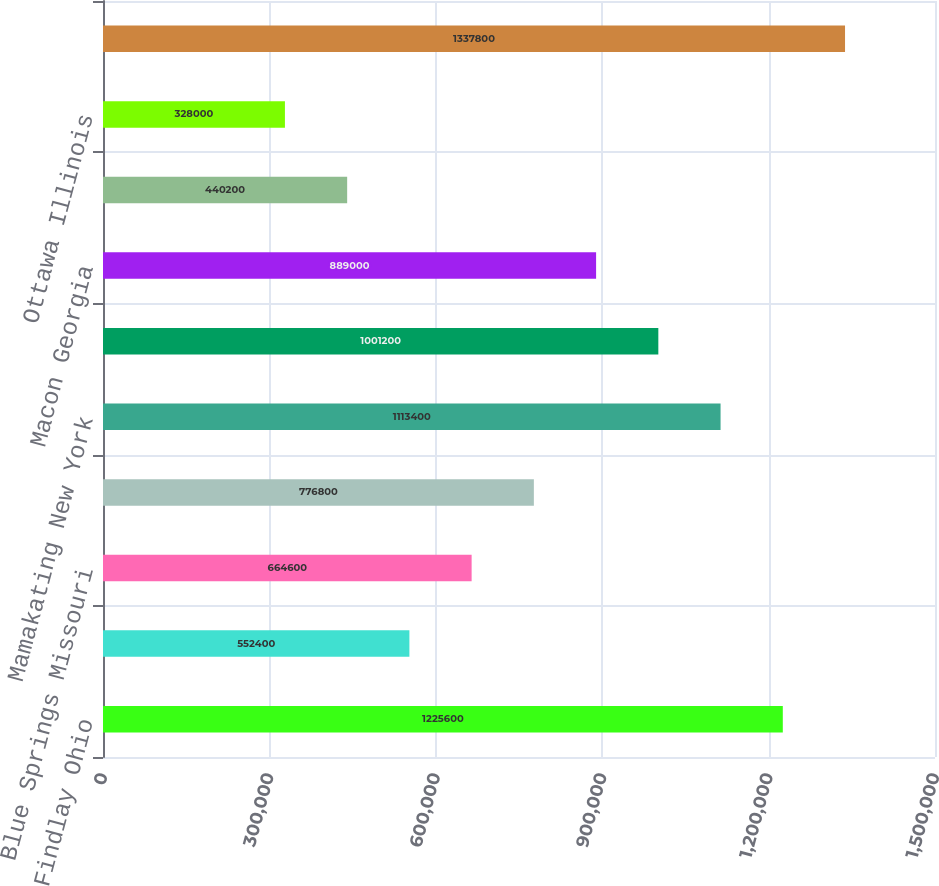Convert chart. <chart><loc_0><loc_0><loc_500><loc_500><bar_chart><fcel>Findlay Ohio<fcel>Winchester Virginia<fcel>Blue Springs Missouri<fcel>Corsicana Texas<fcel>Mamakating New York<fcel>San Bernardino California<fcel>Macon Georgia<fcel>Patterson California<fcel>Ottawa Illinois<fcel>Monroe Ohio<nl><fcel>1.2256e+06<fcel>552400<fcel>664600<fcel>776800<fcel>1.1134e+06<fcel>1.0012e+06<fcel>889000<fcel>440200<fcel>328000<fcel>1.3378e+06<nl></chart> 